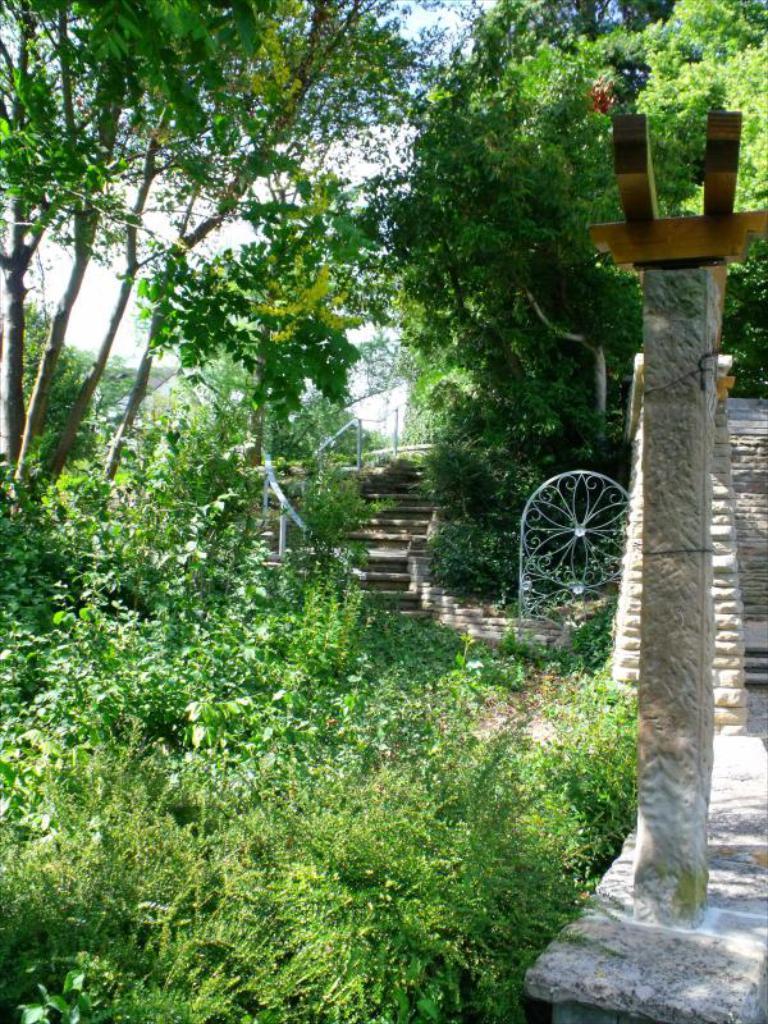Can you describe this image briefly? In this picture I can see there are few plants on to left and there are few stairs in the backdrop and there are trees and the sky is clear. 